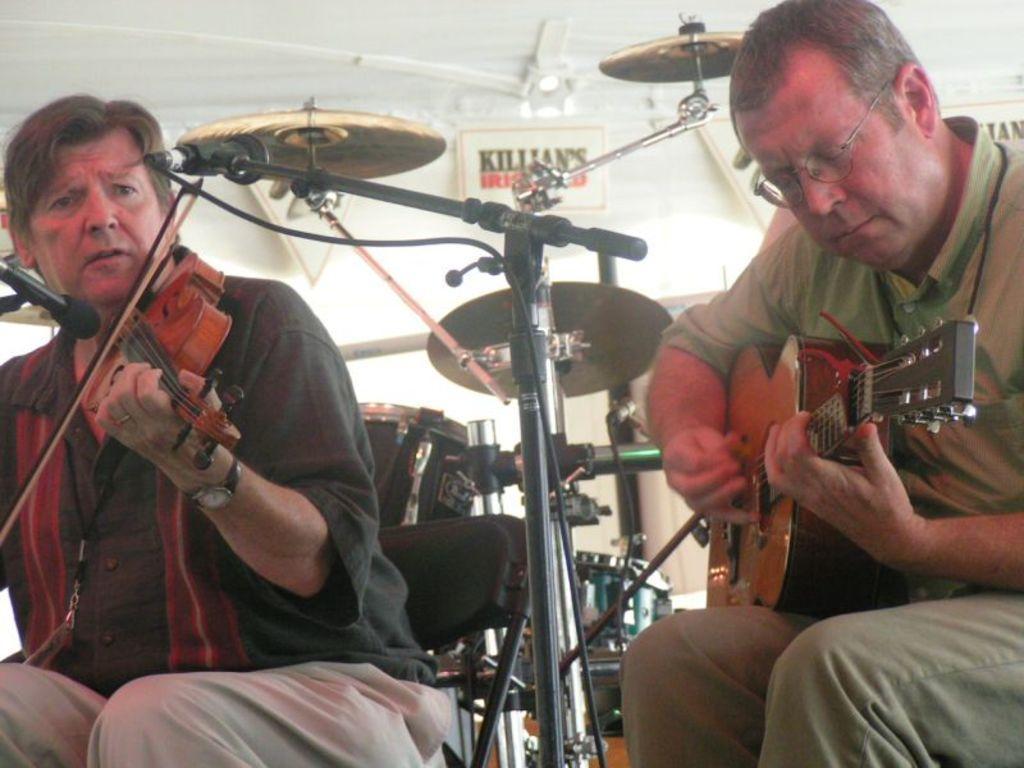Describe this image in one or two sentences. In this image there are two musicians performing at the concert sitting on a chair, the person at a right side is holding a guitar and playing closing his eyes. The person on the left side is sitting on a chair and he is holding musical instrument and playing it. In front of him there is a mic. In the center there is a mic with a stand. In the background there is a musical instrument and a wall. 